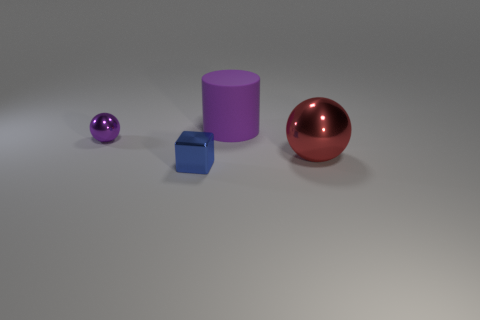Add 2 big rubber objects. How many objects exist? 6 Subtract all cubes. How many objects are left? 3 Add 2 large rubber things. How many large rubber things are left? 3 Add 2 large purple rubber things. How many large purple rubber things exist? 3 Subtract 0 blue cylinders. How many objects are left? 4 Subtract all rubber things. Subtract all gray things. How many objects are left? 3 